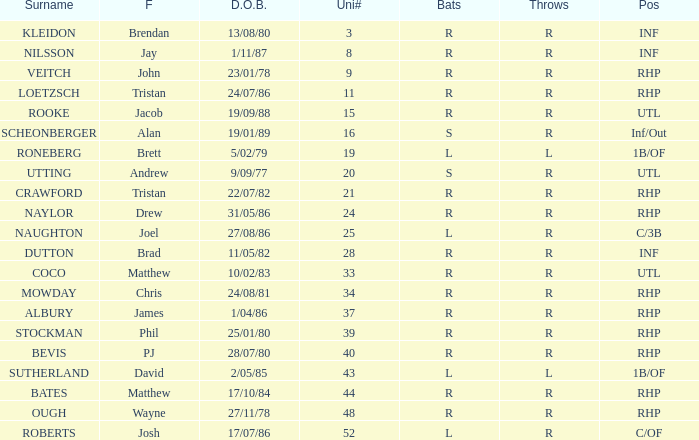Which Position has a Surname of naylor? RHP. 